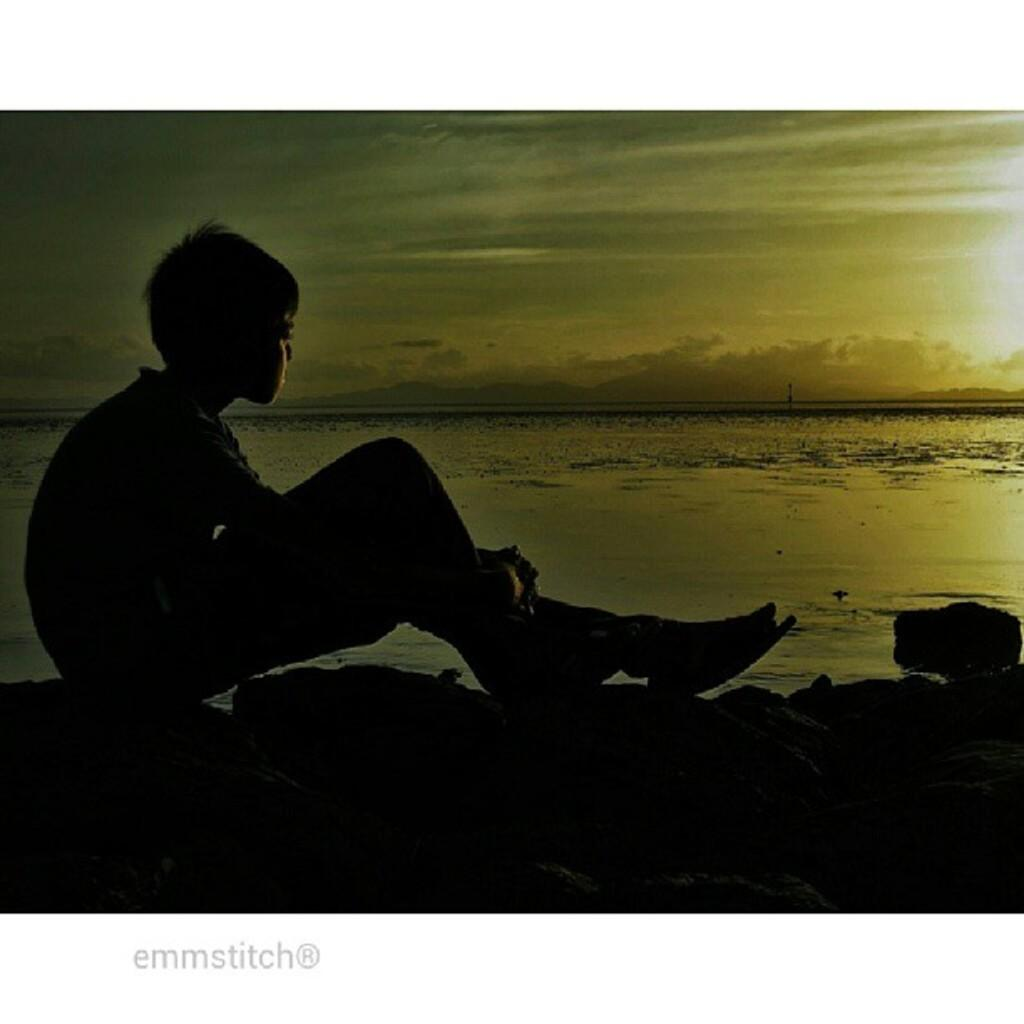Who is in the picture? There is a boy in the picture. What is the boy doing in the picture? The boy is sitting at the seaside. What is the boy's facial expression or direction of gaze? The boy is looking straight. What can be seen in the background of the picture? There is sea water visible in the background of the picture. How many beds are visible in the picture? There are no beds present in the picture; it features a boy sitting at the seaside. 